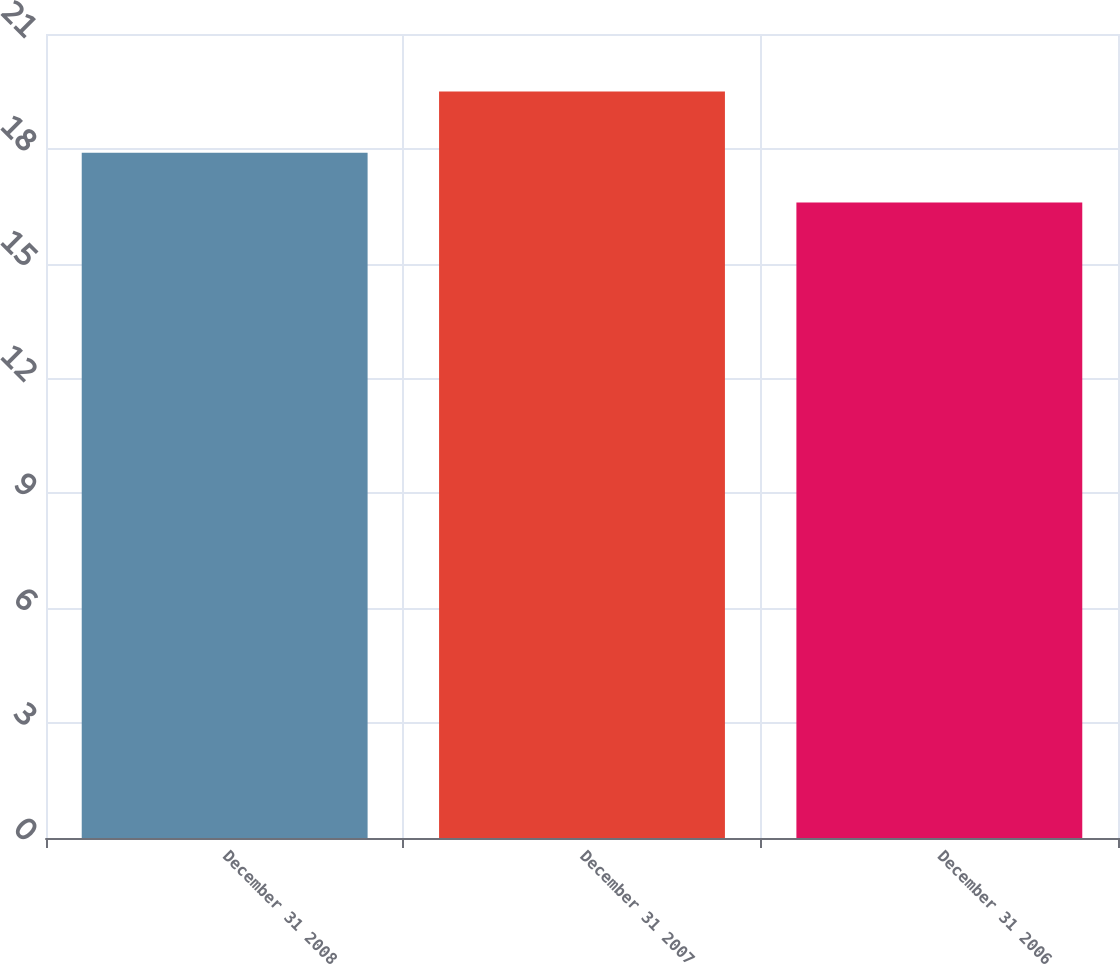<chart> <loc_0><loc_0><loc_500><loc_500><bar_chart><fcel>December 31 2008<fcel>December 31 2007<fcel>December 31 2006<nl><fcel>17.9<fcel>19.5<fcel>16.6<nl></chart> 